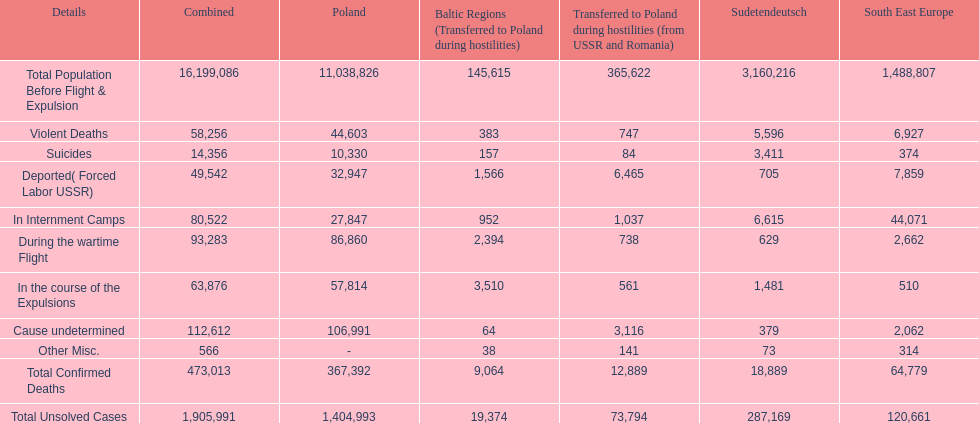What was the cause of the most deaths? Cause undetermined. 